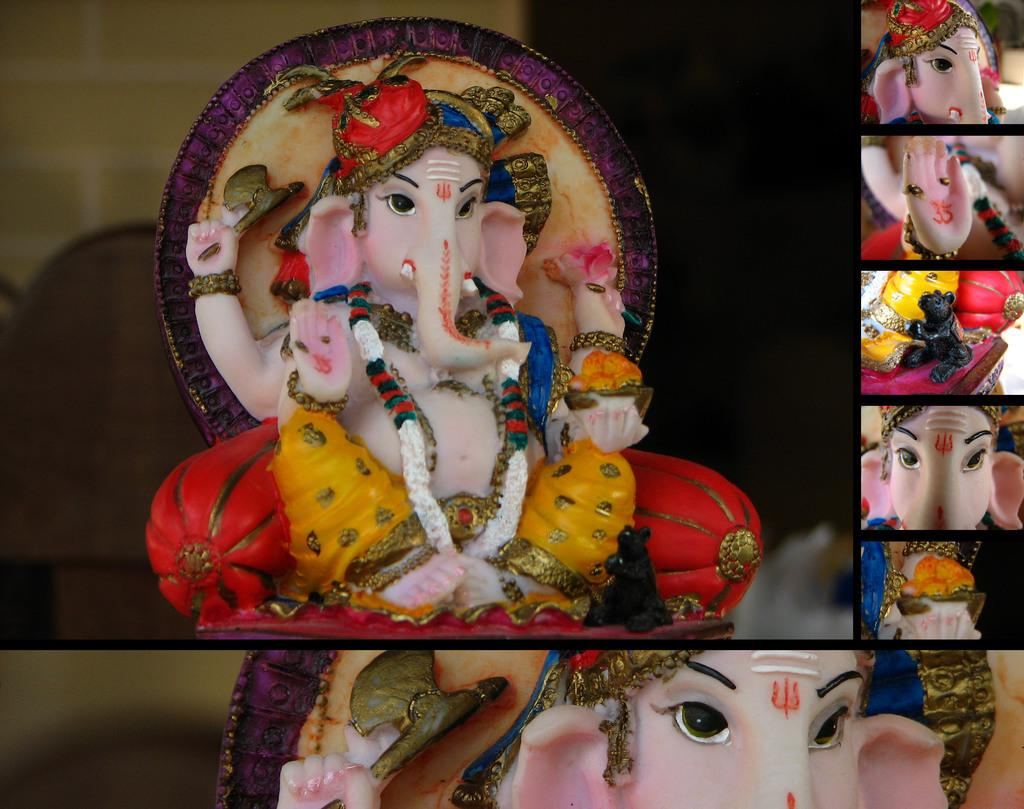What type of objects are depicted in the image? There are idols of god in the image. How is the image composed? The image is a collage picture. What type of houses can be seen in the image? There are no houses present in the image; it features idols of god in a collage. What type of snack is being eaten by the idols in the image? There is no snack, such as popcorn, depicted in the image. 